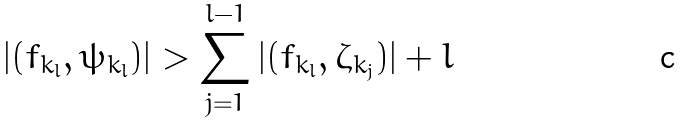<formula> <loc_0><loc_0><loc_500><loc_500>| ( f _ { k _ { l } } , \psi _ { k _ { l } } ) | > \sum _ { j = 1 } ^ { l - 1 } | ( f _ { k _ { l } } , \zeta _ { k _ { j } } ) | + l</formula> 